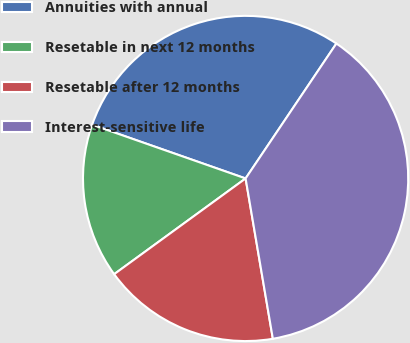<chart> <loc_0><loc_0><loc_500><loc_500><pie_chart><fcel>Annuities with annual<fcel>Resetable in next 12 months<fcel>Resetable after 12 months<fcel>Interest-sensitive life<nl><fcel>29.06%<fcel>15.38%<fcel>17.66%<fcel>37.89%<nl></chart> 